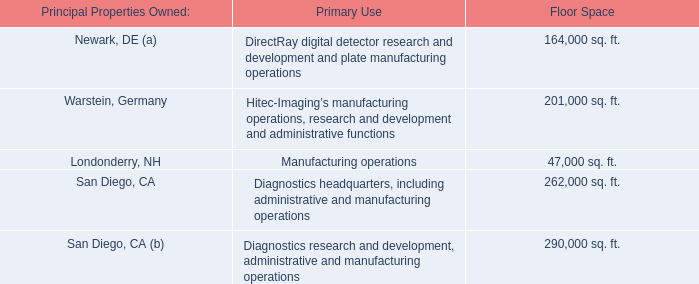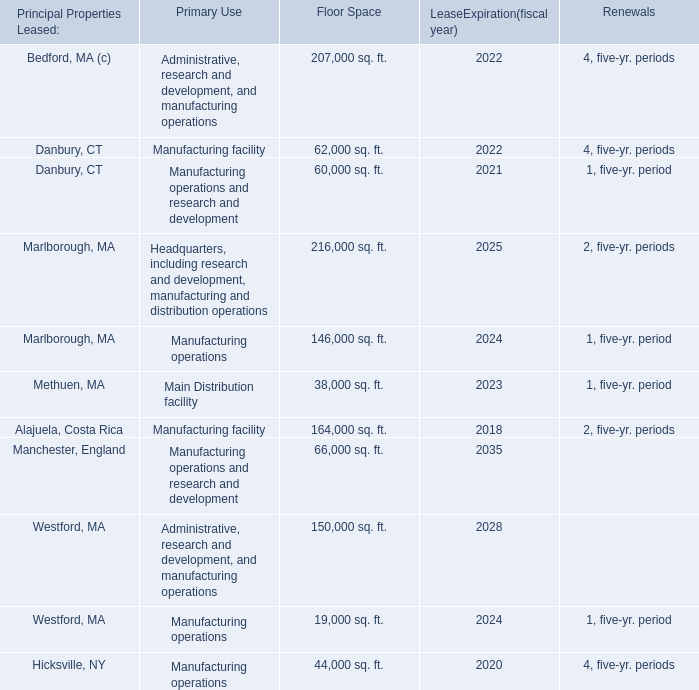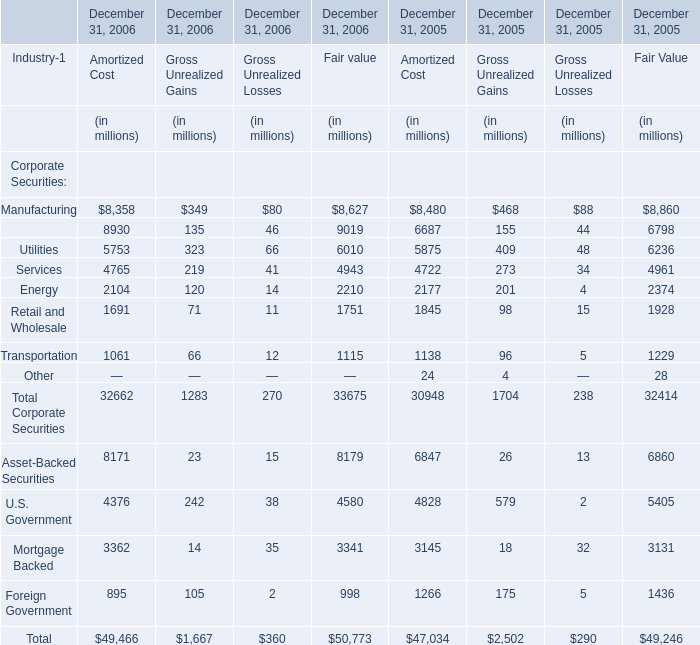What's the growth rate of the Gross Unrealized Gains for Total Corporate Securities on December 31 in 2006? 
Computations: ((1283 - 1704) / 1704)
Answer: -0.24707. 